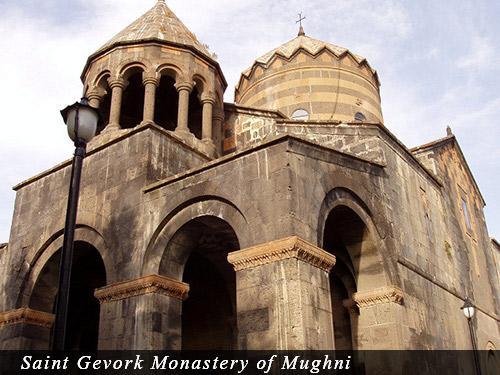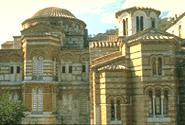The first image is the image on the left, the second image is the image on the right. Given the left and right images, does the statement "An image shows a tall building with a flat top that is notched like a castle." hold true? Answer yes or no. No. 